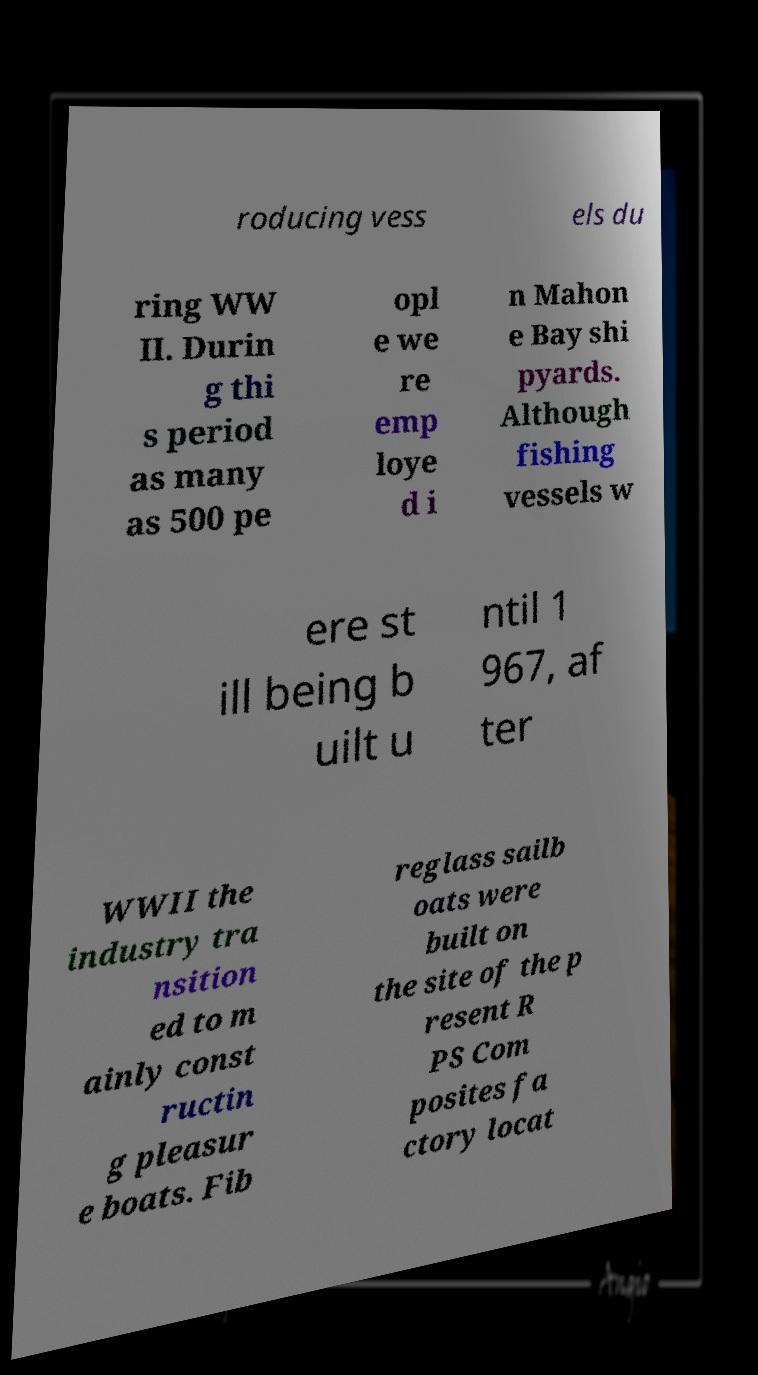Can you read and provide the text displayed in the image?This photo seems to have some interesting text. Can you extract and type it out for me? roducing vess els du ring WW II. Durin g thi s period as many as 500 pe opl e we re emp loye d i n Mahon e Bay shi pyards. Although fishing vessels w ere st ill being b uilt u ntil 1 967, af ter WWII the industry tra nsition ed to m ainly const ructin g pleasur e boats. Fib reglass sailb oats were built on the site of the p resent R PS Com posites fa ctory locat 